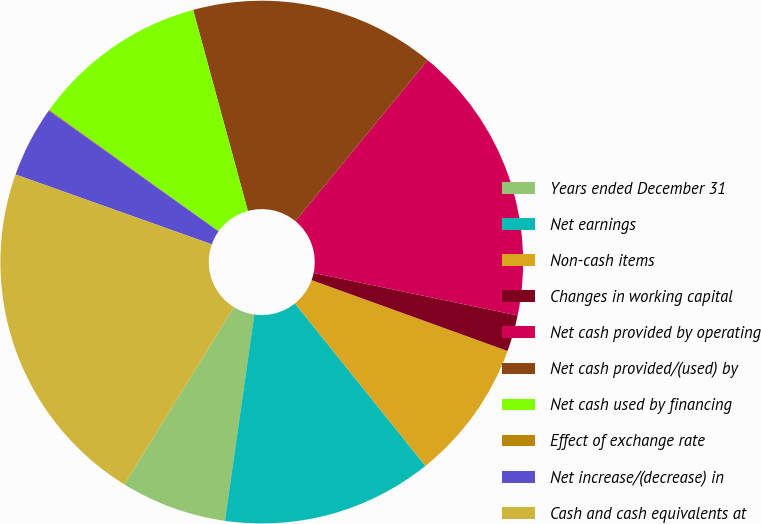<chart> <loc_0><loc_0><loc_500><loc_500><pie_chart><fcel>Years ended December 31<fcel>Net earnings<fcel>Non-cash items<fcel>Changes in working capital<fcel>Net cash provided by operating<fcel>Net cash provided/(used) by<fcel>Net cash used by financing<fcel>Effect of exchange rate<fcel>Net increase/(decrease) in<fcel>Cash and cash equivalents at<nl><fcel>6.56%<fcel>13.02%<fcel>8.71%<fcel>2.25%<fcel>17.33%<fcel>15.17%<fcel>10.87%<fcel>0.06%<fcel>4.4%<fcel>21.63%<nl></chart> 